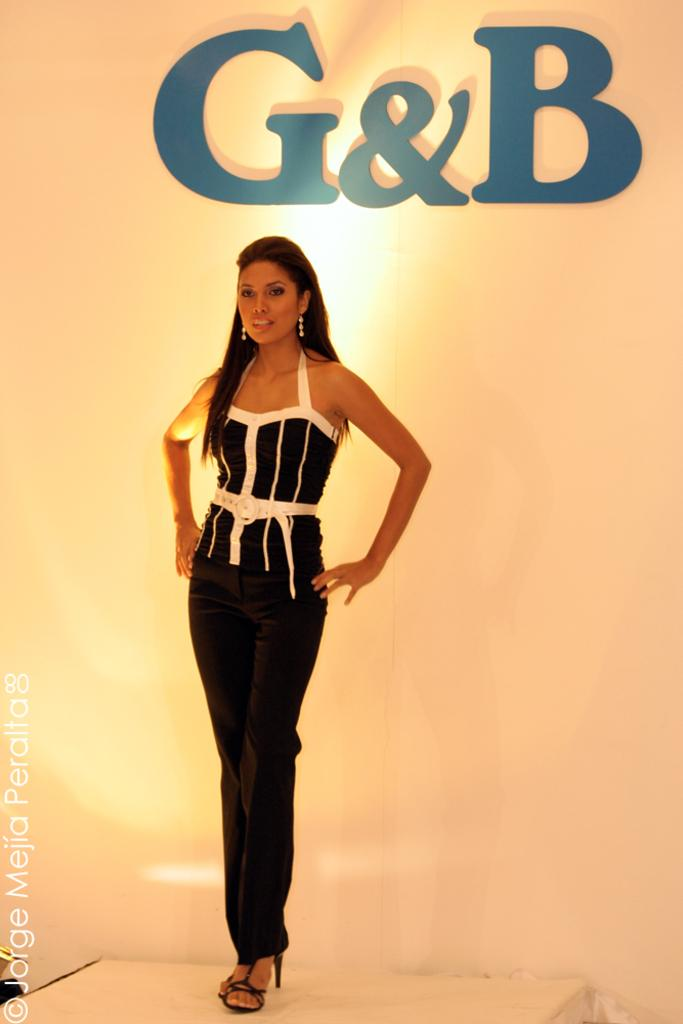What is the main subject of the image? There is a woman standing in the image. What can be seen in the background of the image? There is a logo on a white color wall in the background of the image. Is there any additional information or markings on the image? Yes, there is a watermark in the image. What type of dog is sitting next to the woman in the image? There is no dog present in the image; the main subject is a woman standing. What reward is the woman holding in the image? There is no reward visible in the image; the woman is standing without any objects in her hands. 